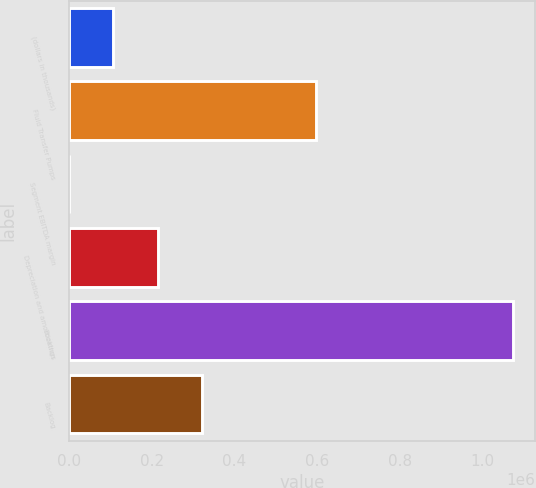<chart> <loc_0><loc_0><loc_500><loc_500><bar_chart><fcel>(dollars in thousands)<fcel>Fluid Transfer Pumps<fcel>Segment EBITDA margin<fcel>Depreciation and amortization<fcel>Bookings<fcel>Backlog<nl><fcel>107385<fcel>596772<fcel>20.6<fcel>214749<fcel>1.07366e+06<fcel>322114<nl></chart> 